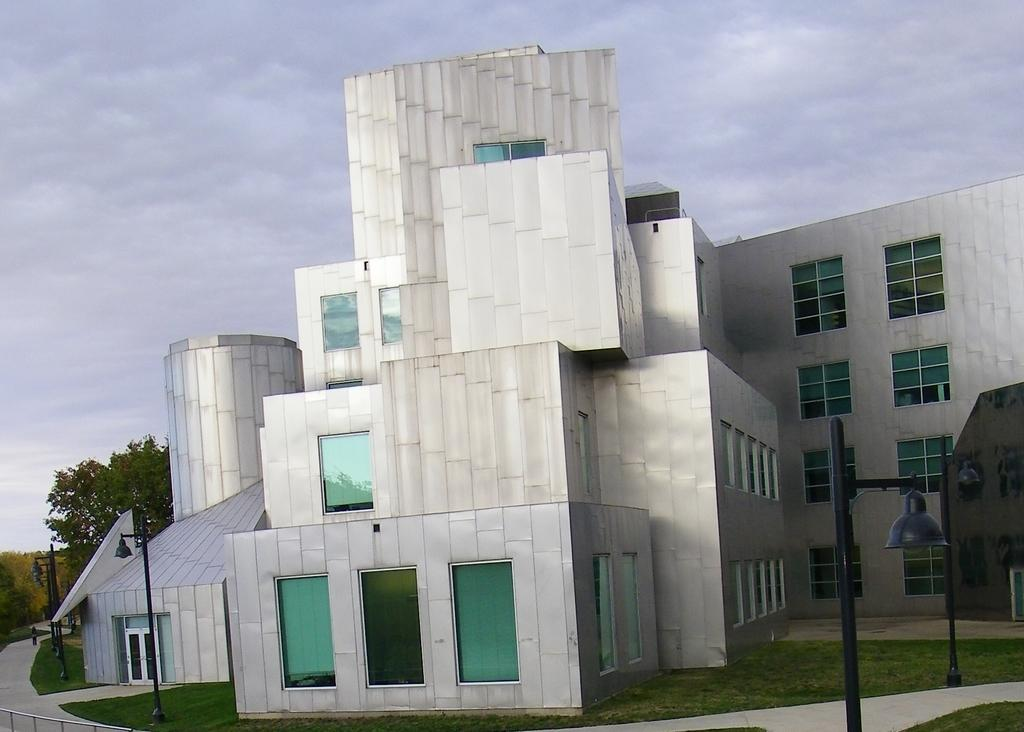What type of structure is the main subject in the image? There is a big building in the image. What feature can be observed on the building? The building has glass windows. What is located in front of the building? There is grass in front of the building. What type of lighting is present in front of the building? There are bell-shaped lights on a pole in front of the building. What can be seen behind the building? There are trees behind the building. Can you tell me how many kitties are playing with yarn inside the building? There is no information about kitties or yarn inside the building in the image. 